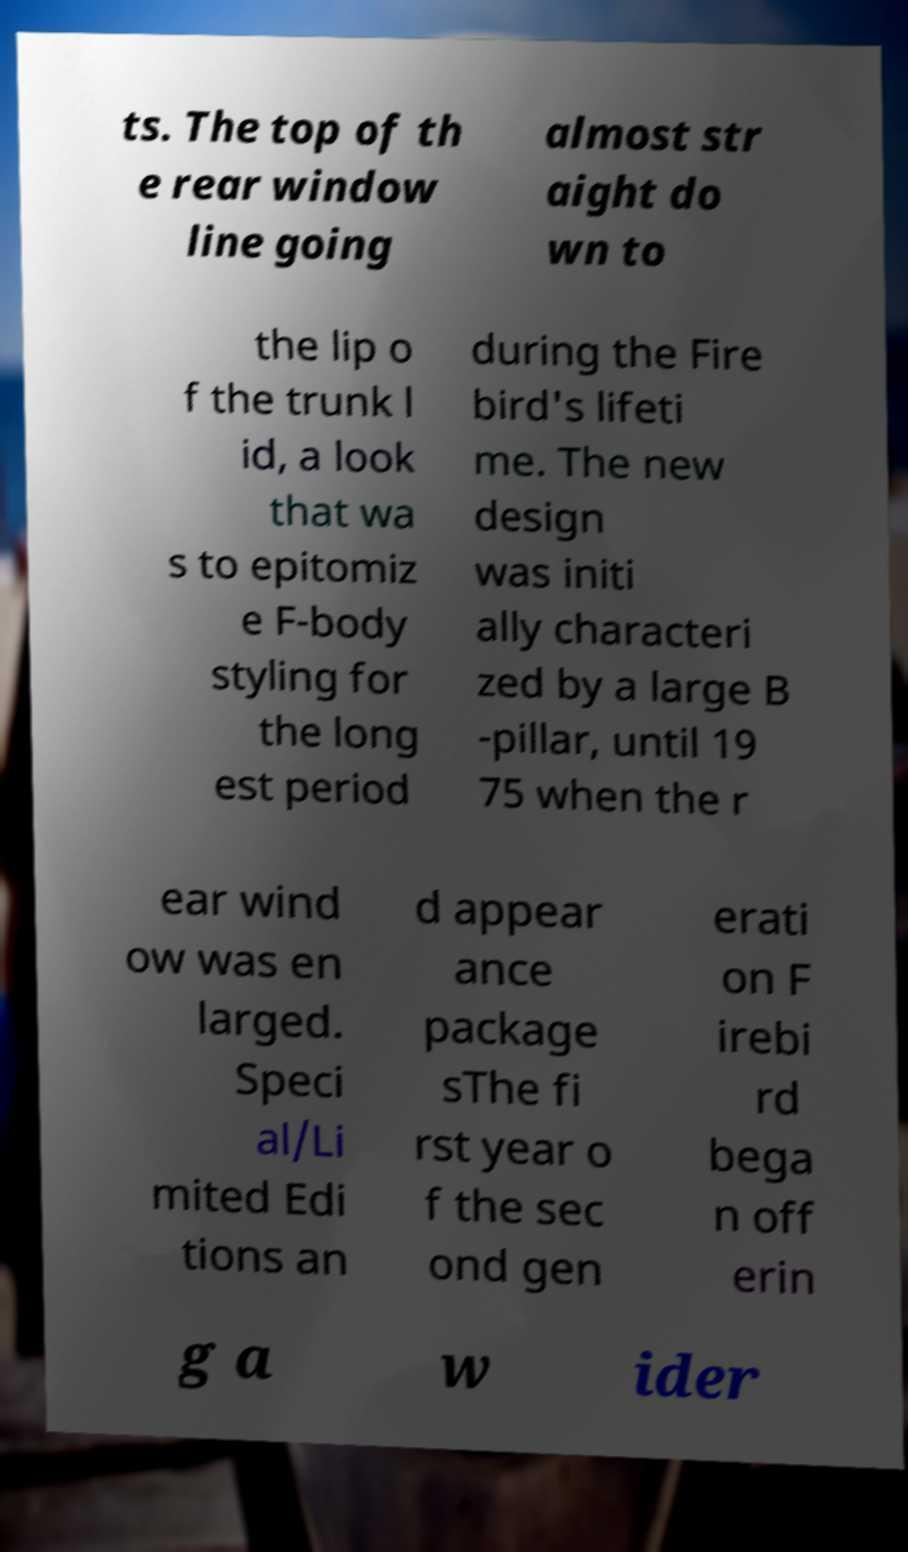For documentation purposes, I need the text within this image transcribed. Could you provide that? ts. The top of th e rear window line going almost str aight do wn to the lip o f the trunk l id, a look that wa s to epitomiz e F-body styling for the long est period during the Fire bird's lifeti me. The new design was initi ally characteri zed by a large B -pillar, until 19 75 when the r ear wind ow was en larged. Speci al/Li mited Edi tions an d appear ance package sThe fi rst year o f the sec ond gen erati on F irebi rd bega n off erin g a w ider 